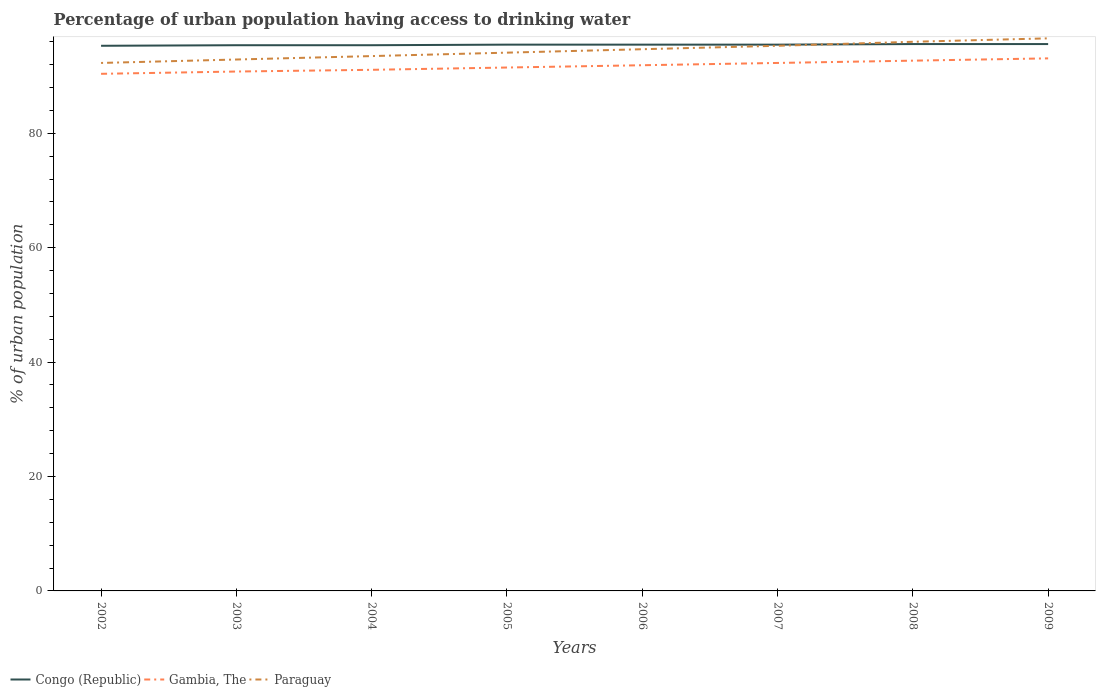How many different coloured lines are there?
Your answer should be compact. 3. Does the line corresponding to Gambia, The intersect with the line corresponding to Paraguay?
Your answer should be very brief. No. Across all years, what is the maximum percentage of urban population having access to drinking water in Congo (Republic)?
Ensure brevity in your answer.  95.3. In which year was the percentage of urban population having access to drinking water in Paraguay maximum?
Your answer should be compact. 2002. What is the total percentage of urban population having access to drinking water in Congo (Republic) in the graph?
Your response must be concise. -0.1. What is the difference between the highest and the second highest percentage of urban population having access to drinking water in Gambia, The?
Your response must be concise. 2.7. Is the percentage of urban population having access to drinking water in Gambia, The strictly greater than the percentage of urban population having access to drinking water in Paraguay over the years?
Your response must be concise. Yes. How many lines are there?
Offer a terse response. 3. Are the values on the major ticks of Y-axis written in scientific E-notation?
Give a very brief answer. No. Does the graph contain any zero values?
Offer a terse response. No. Where does the legend appear in the graph?
Offer a very short reply. Bottom left. How many legend labels are there?
Offer a very short reply. 3. How are the legend labels stacked?
Offer a very short reply. Horizontal. What is the title of the graph?
Your answer should be compact. Percentage of urban population having access to drinking water. Does "United Arab Emirates" appear as one of the legend labels in the graph?
Give a very brief answer. No. What is the label or title of the Y-axis?
Keep it short and to the point. % of urban population. What is the % of urban population of Congo (Republic) in 2002?
Offer a terse response. 95.3. What is the % of urban population of Gambia, The in 2002?
Offer a very short reply. 90.4. What is the % of urban population in Paraguay in 2002?
Provide a short and direct response. 92.3. What is the % of urban population of Congo (Republic) in 2003?
Offer a very short reply. 95.4. What is the % of urban population in Gambia, The in 2003?
Make the answer very short. 90.8. What is the % of urban population in Paraguay in 2003?
Provide a short and direct response. 92.9. What is the % of urban population of Congo (Republic) in 2004?
Keep it short and to the point. 95.4. What is the % of urban population in Gambia, The in 2004?
Your answer should be very brief. 91.1. What is the % of urban population in Paraguay in 2004?
Make the answer very short. 93.5. What is the % of urban population in Congo (Republic) in 2005?
Offer a very short reply. 95.5. What is the % of urban population in Gambia, The in 2005?
Provide a short and direct response. 91.5. What is the % of urban population of Paraguay in 2005?
Offer a terse response. 94.1. What is the % of urban population in Congo (Republic) in 2006?
Make the answer very short. 95.5. What is the % of urban population in Gambia, The in 2006?
Your response must be concise. 91.9. What is the % of urban population of Paraguay in 2006?
Make the answer very short. 94.7. What is the % of urban population in Congo (Republic) in 2007?
Offer a terse response. 95.5. What is the % of urban population in Gambia, The in 2007?
Make the answer very short. 92.3. What is the % of urban population of Paraguay in 2007?
Provide a succinct answer. 95.3. What is the % of urban population in Congo (Republic) in 2008?
Ensure brevity in your answer.  95.6. What is the % of urban population in Gambia, The in 2008?
Your answer should be compact. 92.7. What is the % of urban population of Paraguay in 2008?
Offer a terse response. 96. What is the % of urban population of Congo (Republic) in 2009?
Provide a short and direct response. 95.6. What is the % of urban population in Gambia, The in 2009?
Your answer should be compact. 93.1. What is the % of urban population of Paraguay in 2009?
Your answer should be very brief. 96.6. Across all years, what is the maximum % of urban population in Congo (Republic)?
Offer a terse response. 95.6. Across all years, what is the maximum % of urban population of Gambia, The?
Keep it short and to the point. 93.1. Across all years, what is the maximum % of urban population in Paraguay?
Provide a succinct answer. 96.6. Across all years, what is the minimum % of urban population in Congo (Republic)?
Your response must be concise. 95.3. Across all years, what is the minimum % of urban population of Gambia, The?
Give a very brief answer. 90.4. Across all years, what is the minimum % of urban population in Paraguay?
Your response must be concise. 92.3. What is the total % of urban population in Congo (Republic) in the graph?
Keep it short and to the point. 763.8. What is the total % of urban population of Gambia, The in the graph?
Make the answer very short. 733.8. What is the total % of urban population of Paraguay in the graph?
Your answer should be compact. 755.4. What is the difference between the % of urban population of Paraguay in 2002 and that in 2003?
Ensure brevity in your answer.  -0.6. What is the difference between the % of urban population of Congo (Republic) in 2002 and that in 2004?
Provide a short and direct response. -0.1. What is the difference between the % of urban population in Gambia, The in 2002 and that in 2004?
Your response must be concise. -0.7. What is the difference between the % of urban population in Paraguay in 2002 and that in 2004?
Your response must be concise. -1.2. What is the difference between the % of urban population in Congo (Republic) in 2002 and that in 2006?
Your answer should be very brief. -0.2. What is the difference between the % of urban population in Congo (Republic) in 2002 and that in 2007?
Offer a terse response. -0.2. What is the difference between the % of urban population in Gambia, The in 2002 and that in 2007?
Keep it short and to the point. -1.9. What is the difference between the % of urban population of Gambia, The in 2002 and that in 2008?
Offer a very short reply. -2.3. What is the difference between the % of urban population in Congo (Republic) in 2002 and that in 2009?
Your answer should be compact. -0.3. What is the difference between the % of urban population in Congo (Republic) in 2003 and that in 2004?
Make the answer very short. 0. What is the difference between the % of urban population of Gambia, The in 2003 and that in 2005?
Provide a succinct answer. -0.7. What is the difference between the % of urban population of Congo (Republic) in 2003 and that in 2006?
Keep it short and to the point. -0.1. What is the difference between the % of urban population of Paraguay in 2003 and that in 2006?
Your answer should be compact. -1.8. What is the difference between the % of urban population in Congo (Republic) in 2003 and that in 2007?
Offer a very short reply. -0.1. What is the difference between the % of urban population in Paraguay in 2003 and that in 2007?
Provide a short and direct response. -2.4. What is the difference between the % of urban population in Congo (Republic) in 2003 and that in 2008?
Your response must be concise. -0.2. What is the difference between the % of urban population in Gambia, The in 2003 and that in 2008?
Your answer should be very brief. -1.9. What is the difference between the % of urban population of Paraguay in 2003 and that in 2008?
Your answer should be compact. -3.1. What is the difference between the % of urban population in Gambia, The in 2003 and that in 2009?
Your answer should be compact. -2.3. What is the difference between the % of urban population of Congo (Republic) in 2004 and that in 2005?
Your answer should be compact. -0.1. What is the difference between the % of urban population in Congo (Republic) in 2004 and that in 2006?
Offer a very short reply. -0.1. What is the difference between the % of urban population in Paraguay in 2004 and that in 2006?
Ensure brevity in your answer.  -1.2. What is the difference between the % of urban population of Congo (Republic) in 2004 and that in 2007?
Provide a short and direct response. -0.1. What is the difference between the % of urban population of Gambia, The in 2004 and that in 2007?
Your answer should be compact. -1.2. What is the difference between the % of urban population in Congo (Republic) in 2004 and that in 2008?
Ensure brevity in your answer.  -0.2. What is the difference between the % of urban population of Paraguay in 2004 and that in 2008?
Your answer should be very brief. -2.5. What is the difference between the % of urban population in Gambia, The in 2005 and that in 2006?
Give a very brief answer. -0.4. What is the difference between the % of urban population in Paraguay in 2005 and that in 2006?
Provide a succinct answer. -0.6. What is the difference between the % of urban population in Congo (Republic) in 2005 and that in 2007?
Give a very brief answer. 0. What is the difference between the % of urban population of Gambia, The in 2005 and that in 2007?
Your response must be concise. -0.8. What is the difference between the % of urban population in Paraguay in 2005 and that in 2007?
Make the answer very short. -1.2. What is the difference between the % of urban population in Congo (Republic) in 2005 and that in 2008?
Your answer should be very brief. -0.1. What is the difference between the % of urban population in Paraguay in 2005 and that in 2009?
Your answer should be very brief. -2.5. What is the difference between the % of urban population in Gambia, The in 2006 and that in 2007?
Provide a short and direct response. -0.4. What is the difference between the % of urban population of Congo (Republic) in 2007 and that in 2008?
Make the answer very short. -0.1. What is the difference between the % of urban population of Gambia, The in 2007 and that in 2008?
Provide a succinct answer. -0.4. What is the difference between the % of urban population of Paraguay in 2007 and that in 2009?
Offer a terse response. -1.3. What is the difference between the % of urban population of Congo (Republic) in 2008 and that in 2009?
Provide a short and direct response. 0. What is the difference between the % of urban population in Gambia, The in 2008 and that in 2009?
Give a very brief answer. -0.4. What is the difference between the % of urban population of Congo (Republic) in 2002 and the % of urban population of Paraguay in 2003?
Offer a very short reply. 2.4. What is the difference between the % of urban population in Gambia, The in 2002 and the % of urban population in Paraguay in 2003?
Ensure brevity in your answer.  -2.5. What is the difference between the % of urban population of Congo (Republic) in 2002 and the % of urban population of Gambia, The in 2004?
Keep it short and to the point. 4.2. What is the difference between the % of urban population in Gambia, The in 2002 and the % of urban population in Paraguay in 2004?
Provide a succinct answer. -3.1. What is the difference between the % of urban population of Congo (Republic) in 2002 and the % of urban population of Gambia, The in 2005?
Provide a succinct answer. 3.8. What is the difference between the % of urban population of Congo (Republic) in 2002 and the % of urban population of Paraguay in 2005?
Give a very brief answer. 1.2. What is the difference between the % of urban population of Congo (Republic) in 2002 and the % of urban population of Paraguay in 2006?
Give a very brief answer. 0.6. What is the difference between the % of urban population of Gambia, The in 2002 and the % of urban population of Paraguay in 2006?
Offer a very short reply. -4.3. What is the difference between the % of urban population in Congo (Republic) in 2002 and the % of urban population in Paraguay in 2008?
Provide a succinct answer. -0.7. What is the difference between the % of urban population in Gambia, The in 2002 and the % of urban population in Paraguay in 2008?
Make the answer very short. -5.6. What is the difference between the % of urban population of Congo (Republic) in 2002 and the % of urban population of Gambia, The in 2009?
Offer a terse response. 2.2. What is the difference between the % of urban population of Congo (Republic) in 2002 and the % of urban population of Paraguay in 2009?
Ensure brevity in your answer.  -1.3. What is the difference between the % of urban population in Gambia, The in 2002 and the % of urban population in Paraguay in 2009?
Ensure brevity in your answer.  -6.2. What is the difference between the % of urban population in Congo (Republic) in 2003 and the % of urban population in Gambia, The in 2005?
Your answer should be very brief. 3.9. What is the difference between the % of urban population in Congo (Republic) in 2003 and the % of urban population in Gambia, The in 2006?
Your answer should be compact. 3.5. What is the difference between the % of urban population of Congo (Republic) in 2003 and the % of urban population of Gambia, The in 2007?
Your answer should be very brief. 3.1. What is the difference between the % of urban population in Gambia, The in 2003 and the % of urban population in Paraguay in 2007?
Make the answer very short. -4.5. What is the difference between the % of urban population in Congo (Republic) in 2003 and the % of urban population in Gambia, The in 2008?
Provide a short and direct response. 2.7. What is the difference between the % of urban population in Congo (Republic) in 2004 and the % of urban population in Paraguay in 2005?
Offer a very short reply. 1.3. What is the difference between the % of urban population in Congo (Republic) in 2004 and the % of urban population in Paraguay in 2006?
Provide a short and direct response. 0.7. What is the difference between the % of urban population in Gambia, The in 2004 and the % of urban population in Paraguay in 2007?
Your response must be concise. -4.2. What is the difference between the % of urban population in Congo (Republic) in 2004 and the % of urban population in Gambia, The in 2009?
Offer a terse response. 2.3. What is the difference between the % of urban population in Congo (Republic) in 2004 and the % of urban population in Paraguay in 2009?
Your answer should be very brief. -1.2. What is the difference between the % of urban population of Congo (Republic) in 2005 and the % of urban population of Paraguay in 2006?
Your answer should be compact. 0.8. What is the difference between the % of urban population of Congo (Republic) in 2005 and the % of urban population of Paraguay in 2007?
Your response must be concise. 0.2. What is the difference between the % of urban population of Gambia, The in 2005 and the % of urban population of Paraguay in 2007?
Your answer should be compact. -3.8. What is the difference between the % of urban population in Congo (Republic) in 2005 and the % of urban population in Gambia, The in 2008?
Give a very brief answer. 2.8. What is the difference between the % of urban population of Gambia, The in 2005 and the % of urban population of Paraguay in 2008?
Your answer should be very brief. -4.5. What is the difference between the % of urban population of Congo (Republic) in 2005 and the % of urban population of Paraguay in 2009?
Your answer should be compact. -1.1. What is the difference between the % of urban population of Congo (Republic) in 2006 and the % of urban population of Gambia, The in 2007?
Keep it short and to the point. 3.2. What is the difference between the % of urban population in Congo (Republic) in 2006 and the % of urban population in Paraguay in 2007?
Ensure brevity in your answer.  0.2. What is the difference between the % of urban population in Gambia, The in 2006 and the % of urban population in Paraguay in 2008?
Your response must be concise. -4.1. What is the difference between the % of urban population in Congo (Republic) in 2006 and the % of urban population in Gambia, The in 2009?
Keep it short and to the point. 2.4. What is the difference between the % of urban population in Congo (Republic) in 2006 and the % of urban population in Paraguay in 2009?
Provide a short and direct response. -1.1. What is the difference between the % of urban population of Congo (Republic) in 2007 and the % of urban population of Paraguay in 2008?
Ensure brevity in your answer.  -0.5. What is the difference between the % of urban population in Congo (Republic) in 2007 and the % of urban population in Paraguay in 2009?
Offer a terse response. -1.1. What is the difference between the % of urban population of Gambia, The in 2007 and the % of urban population of Paraguay in 2009?
Provide a succinct answer. -4.3. What is the difference between the % of urban population in Congo (Republic) in 2008 and the % of urban population in Gambia, The in 2009?
Keep it short and to the point. 2.5. What is the average % of urban population in Congo (Republic) per year?
Keep it short and to the point. 95.47. What is the average % of urban population in Gambia, The per year?
Keep it short and to the point. 91.72. What is the average % of urban population in Paraguay per year?
Your response must be concise. 94.42. In the year 2002, what is the difference between the % of urban population of Congo (Republic) and % of urban population of Gambia, The?
Offer a terse response. 4.9. In the year 2002, what is the difference between the % of urban population in Congo (Republic) and % of urban population in Paraguay?
Ensure brevity in your answer.  3. In the year 2003, what is the difference between the % of urban population of Congo (Republic) and % of urban population of Paraguay?
Keep it short and to the point. 2.5. In the year 2003, what is the difference between the % of urban population of Gambia, The and % of urban population of Paraguay?
Provide a succinct answer. -2.1. In the year 2004, what is the difference between the % of urban population in Congo (Republic) and % of urban population in Gambia, The?
Ensure brevity in your answer.  4.3. In the year 2006, what is the difference between the % of urban population in Congo (Republic) and % of urban population in Gambia, The?
Make the answer very short. 3.6. In the year 2007, what is the difference between the % of urban population in Congo (Republic) and % of urban population in Gambia, The?
Provide a short and direct response. 3.2. In the year 2008, what is the difference between the % of urban population of Gambia, The and % of urban population of Paraguay?
Offer a very short reply. -3.3. What is the ratio of the % of urban population of Paraguay in 2002 to that in 2003?
Give a very brief answer. 0.99. What is the ratio of the % of urban population of Paraguay in 2002 to that in 2004?
Give a very brief answer. 0.99. What is the ratio of the % of urban population in Paraguay in 2002 to that in 2005?
Your response must be concise. 0.98. What is the ratio of the % of urban population in Congo (Republic) in 2002 to that in 2006?
Give a very brief answer. 1. What is the ratio of the % of urban population of Gambia, The in 2002 to that in 2006?
Ensure brevity in your answer.  0.98. What is the ratio of the % of urban population of Paraguay in 2002 to that in 2006?
Keep it short and to the point. 0.97. What is the ratio of the % of urban population of Gambia, The in 2002 to that in 2007?
Offer a very short reply. 0.98. What is the ratio of the % of urban population in Paraguay in 2002 to that in 2007?
Give a very brief answer. 0.97. What is the ratio of the % of urban population of Gambia, The in 2002 to that in 2008?
Your response must be concise. 0.98. What is the ratio of the % of urban population of Paraguay in 2002 to that in 2008?
Your response must be concise. 0.96. What is the ratio of the % of urban population in Gambia, The in 2002 to that in 2009?
Provide a short and direct response. 0.97. What is the ratio of the % of urban population of Paraguay in 2002 to that in 2009?
Your answer should be compact. 0.96. What is the ratio of the % of urban population in Congo (Republic) in 2003 to that in 2004?
Your answer should be very brief. 1. What is the ratio of the % of urban population in Gambia, The in 2003 to that in 2004?
Provide a succinct answer. 1. What is the ratio of the % of urban population of Paraguay in 2003 to that in 2004?
Your answer should be compact. 0.99. What is the ratio of the % of urban population of Congo (Republic) in 2003 to that in 2005?
Ensure brevity in your answer.  1. What is the ratio of the % of urban population in Gambia, The in 2003 to that in 2005?
Provide a succinct answer. 0.99. What is the ratio of the % of urban population in Paraguay in 2003 to that in 2005?
Offer a terse response. 0.99. What is the ratio of the % of urban population in Gambia, The in 2003 to that in 2007?
Your answer should be compact. 0.98. What is the ratio of the % of urban population in Paraguay in 2003 to that in 2007?
Make the answer very short. 0.97. What is the ratio of the % of urban population in Gambia, The in 2003 to that in 2008?
Give a very brief answer. 0.98. What is the ratio of the % of urban population of Congo (Republic) in 2003 to that in 2009?
Ensure brevity in your answer.  1. What is the ratio of the % of urban population in Gambia, The in 2003 to that in 2009?
Make the answer very short. 0.98. What is the ratio of the % of urban population of Paraguay in 2003 to that in 2009?
Your response must be concise. 0.96. What is the ratio of the % of urban population of Gambia, The in 2004 to that in 2005?
Provide a short and direct response. 1. What is the ratio of the % of urban population of Congo (Republic) in 2004 to that in 2006?
Provide a short and direct response. 1. What is the ratio of the % of urban population in Gambia, The in 2004 to that in 2006?
Provide a short and direct response. 0.99. What is the ratio of the % of urban population in Paraguay in 2004 to that in 2006?
Keep it short and to the point. 0.99. What is the ratio of the % of urban population of Congo (Republic) in 2004 to that in 2007?
Provide a short and direct response. 1. What is the ratio of the % of urban population of Gambia, The in 2004 to that in 2007?
Offer a very short reply. 0.99. What is the ratio of the % of urban population of Paraguay in 2004 to that in 2007?
Give a very brief answer. 0.98. What is the ratio of the % of urban population of Gambia, The in 2004 to that in 2008?
Provide a short and direct response. 0.98. What is the ratio of the % of urban population in Gambia, The in 2004 to that in 2009?
Your answer should be compact. 0.98. What is the ratio of the % of urban population in Paraguay in 2004 to that in 2009?
Make the answer very short. 0.97. What is the ratio of the % of urban population in Congo (Republic) in 2005 to that in 2006?
Give a very brief answer. 1. What is the ratio of the % of urban population of Gambia, The in 2005 to that in 2007?
Offer a terse response. 0.99. What is the ratio of the % of urban population of Paraguay in 2005 to that in 2007?
Provide a succinct answer. 0.99. What is the ratio of the % of urban population of Gambia, The in 2005 to that in 2008?
Provide a short and direct response. 0.99. What is the ratio of the % of urban population in Paraguay in 2005 to that in 2008?
Your answer should be compact. 0.98. What is the ratio of the % of urban population of Congo (Republic) in 2005 to that in 2009?
Offer a very short reply. 1. What is the ratio of the % of urban population in Gambia, The in 2005 to that in 2009?
Give a very brief answer. 0.98. What is the ratio of the % of urban population in Paraguay in 2005 to that in 2009?
Your response must be concise. 0.97. What is the ratio of the % of urban population in Gambia, The in 2006 to that in 2007?
Your answer should be very brief. 1. What is the ratio of the % of urban population of Paraguay in 2006 to that in 2007?
Provide a succinct answer. 0.99. What is the ratio of the % of urban population of Paraguay in 2006 to that in 2008?
Give a very brief answer. 0.99. What is the ratio of the % of urban population of Gambia, The in 2006 to that in 2009?
Make the answer very short. 0.99. What is the ratio of the % of urban population in Paraguay in 2006 to that in 2009?
Your response must be concise. 0.98. What is the ratio of the % of urban population of Gambia, The in 2007 to that in 2008?
Make the answer very short. 1. What is the ratio of the % of urban population in Paraguay in 2007 to that in 2008?
Your answer should be compact. 0.99. What is the ratio of the % of urban population of Congo (Republic) in 2007 to that in 2009?
Ensure brevity in your answer.  1. What is the ratio of the % of urban population of Paraguay in 2007 to that in 2009?
Your response must be concise. 0.99. What is the ratio of the % of urban population of Paraguay in 2008 to that in 2009?
Provide a succinct answer. 0.99. What is the difference between the highest and the second highest % of urban population of Gambia, The?
Give a very brief answer. 0.4. What is the difference between the highest and the second highest % of urban population in Paraguay?
Give a very brief answer. 0.6. What is the difference between the highest and the lowest % of urban population in Gambia, The?
Keep it short and to the point. 2.7. 